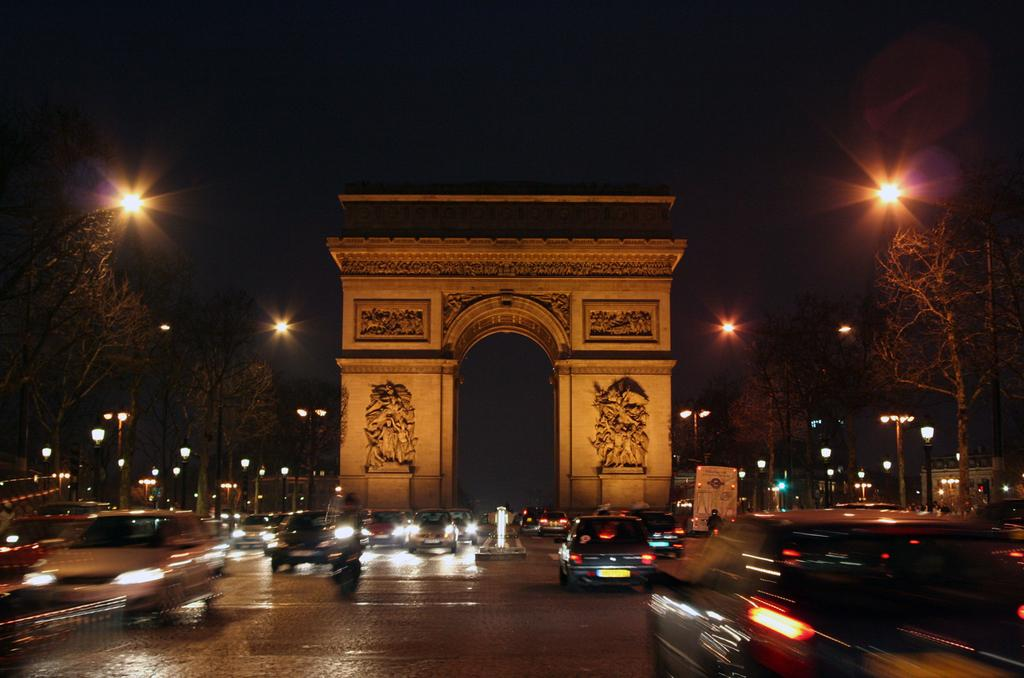What can be seen on the road in the image? There are vehicles on the road in the image. What structure is present with a design in the image? There is an arch with some design in the image. What type of natural elements can be seen in the image? There are trees visible in the image. What can be seen providing illumination in the image? There are lights visible in the image. What type of skin can be seen on the vehicles in the image? There is no mention of skin in the image, as it features vehicles on the road, an arch, trees, and lights. What type of beef is being served at the restaurant in the image? There is no restaurant or beef present in the image; it features vehicles on the road, an arch, trees, and lights. 